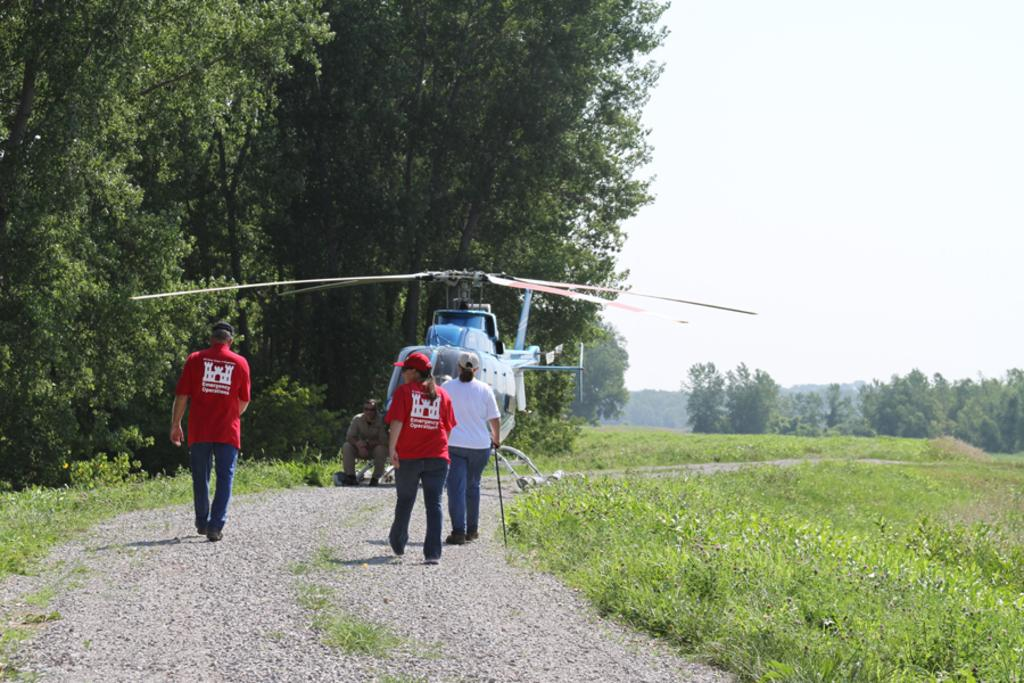What are the people in the image doing? There are three people walking in the image. What is the man in the image doing? There is a man sitting in the image. What can be seen in the sky in the image? The sky is visible in the background of the image. What type of vegetation is visible in the image? There are trees in the background of the image, and grass is visible in the image. What else is present in the image? There is an airplane in the image. What type of ornament is hanging from the tree in the image? There is no ornament hanging from the tree in the image; only trees and grass are visible. How does the cat feel about the people walking in the image? There is no cat present in the image, so it is not possible to determine how a cat might feel about the people walking. 